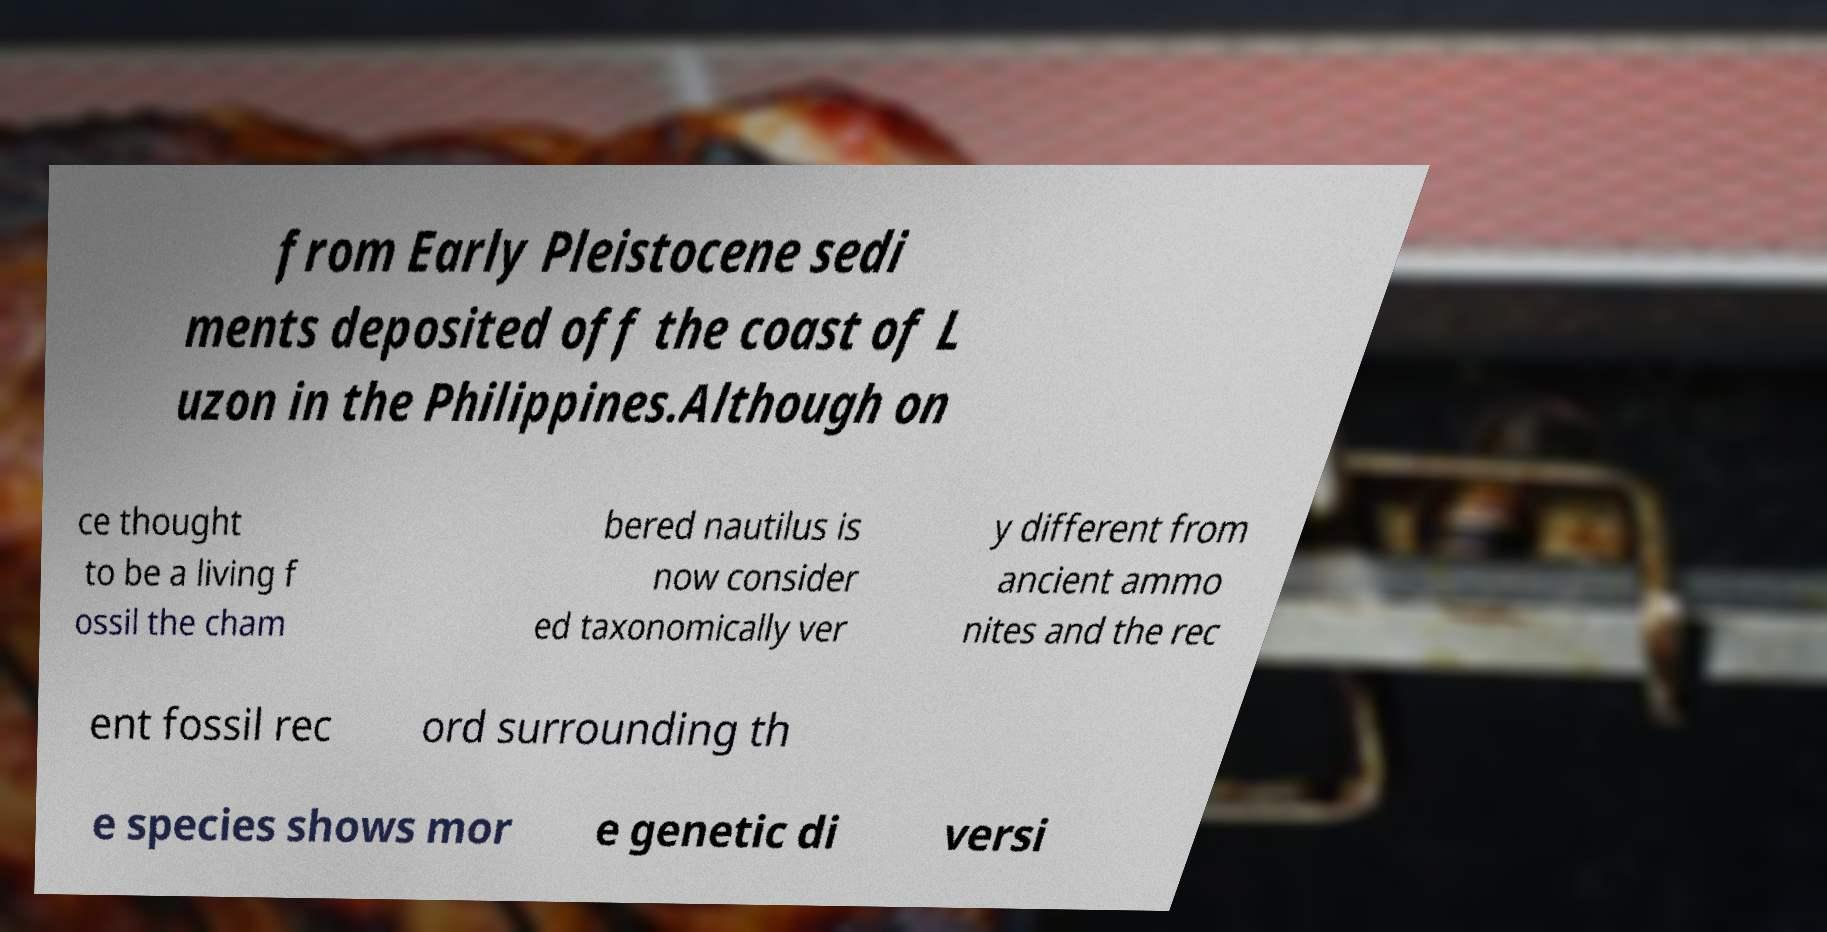Could you extract and type out the text from this image? from Early Pleistocene sedi ments deposited off the coast of L uzon in the Philippines.Although on ce thought to be a living f ossil the cham bered nautilus is now consider ed taxonomically ver y different from ancient ammo nites and the rec ent fossil rec ord surrounding th e species shows mor e genetic di versi 